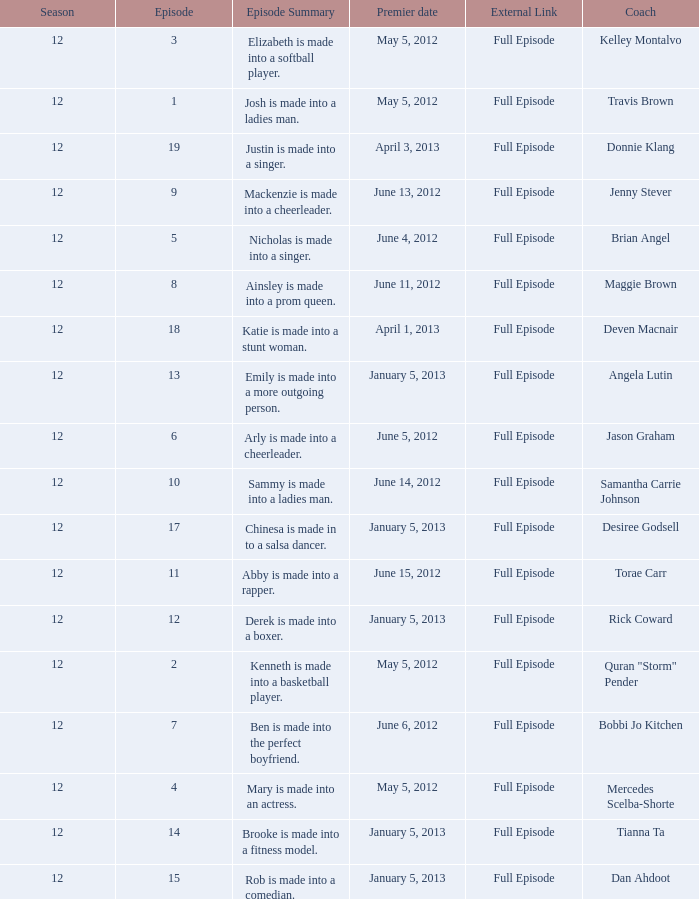Would you mind parsing the complete table? {'header': ['Season', 'Episode', 'Episode Summary', 'Premier date', 'External Link', 'Coach'], 'rows': [['12', '3', 'Elizabeth is made into a softball player.', 'May 5, 2012', 'Full Episode', 'Kelley Montalvo'], ['12', '1', 'Josh is made into a ladies man.', 'May 5, 2012', 'Full Episode', 'Travis Brown'], ['12', '19', 'Justin is made into a singer.', 'April 3, 2013', 'Full Episode', 'Donnie Klang'], ['12', '9', 'Mackenzie is made into a cheerleader.', 'June 13, 2012', 'Full Episode', 'Jenny Stever'], ['12', '5', 'Nicholas is made into a singer.', 'June 4, 2012', 'Full Episode', 'Brian Angel'], ['12', '8', 'Ainsley is made into a prom queen.', 'June 11, 2012', 'Full Episode', 'Maggie Brown'], ['12', '18', 'Katie is made into a stunt woman.', 'April 1, 2013', 'Full Episode', 'Deven Macnair'], ['12', '13', 'Emily is made into a more outgoing person.', 'January 5, 2013', 'Full Episode', 'Angela Lutin'], ['12', '6', 'Arly is made into a cheerleader.', 'June 5, 2012', 'Full Episode', 'Jason Graham'], ['12', '10', 'Sammy is made into a ladies man.', 'June 14, 2012', 'Full Episode', 'Samantha Carrie Johnson'], ['12', '17', 'Chinesa is made in to a salsa dancer.', 'January 5, 2013', 'Full Episode', 'Desiree Godsell'], ['12', '11', 'Abby is made into a rapper.', 'June 15, 2012', 'Full Episode', 'Torae Carr'], ['12', '12', 'Derek is made into a boxer.', 'January 5, 2013', 'Full Episode', 'Rick Coward'], ['12', '2', 'Kenneth is made into a basketball player.', 'May 5, 2012', 'Full Episode', 'Quran "Storm" Pender'], ['12', '7', 'Ben is made into the perfect boyfriend.', 'June 6, 2012', 'Full Episode', 'Bobbi Jo Kitchen'], ['12', '4', 'Mary is made into an actress.', 'May 5, 2012', 'Full Episode', 'Mercedes Scelba-Shorte'], ['12', '14', 'Brooke is made into a fitness model.', 'January 5, 2013', 'Full Episode', 'Tianna Ta'], ['12', '15', 'Rob is made into a comedian.', 'January 5, 2013', 'Full Episode', 'Dan Ahdoot']]} Name the episode for travis brown 1.0. 